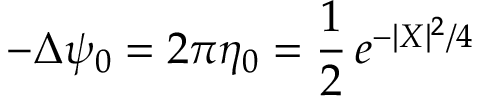<formula> <loc_0><loc_0><loc_500><loc_500>- \Delta \psi _ { 0 } = 2 \pi \eta _ { 0 } = \frac { 1 } { 2 } \, e ^ { - | X | ^ { 2 } / 4 }</formula> 